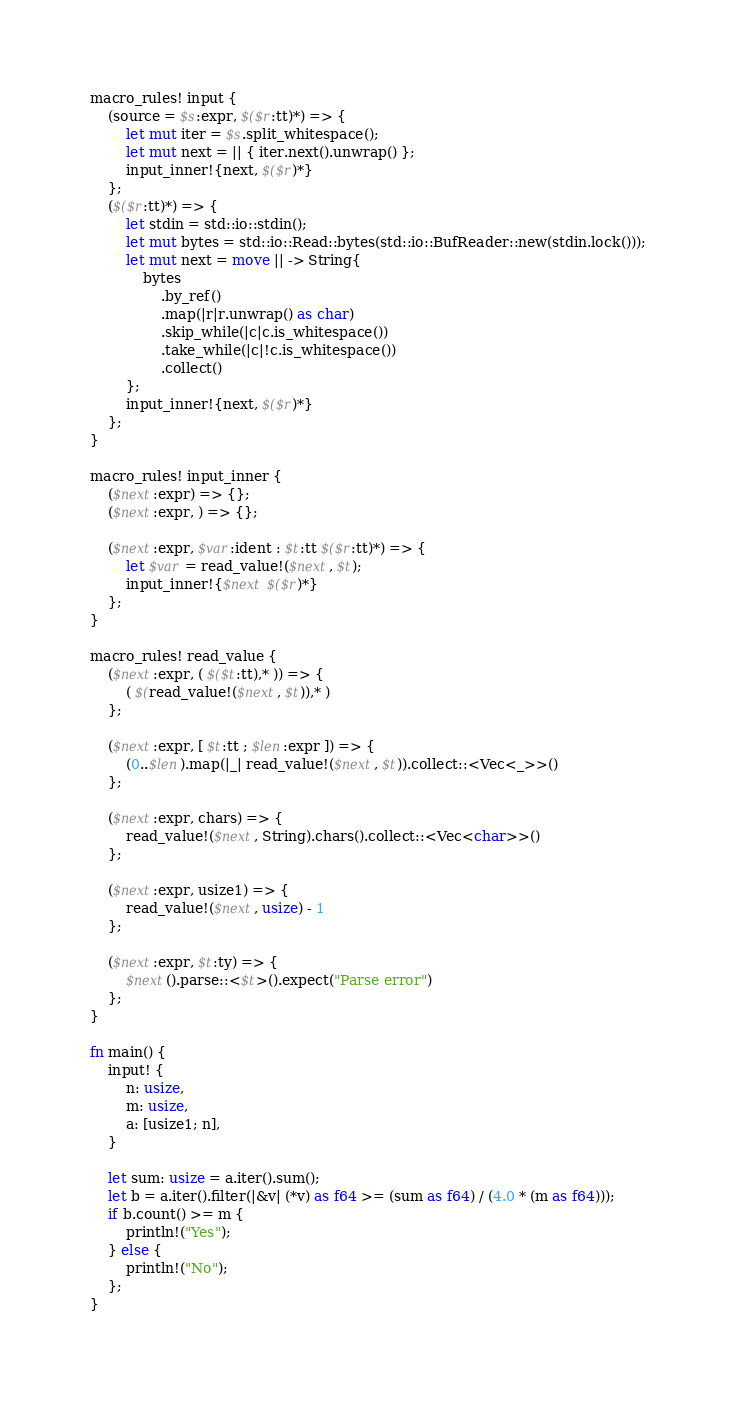<code> <loc_0><loc_0><loc_500><loc_500><_Rust_>macro_rules! input {
    (source = $s:expr, $($r:tt)*) => {
        let mut iter = $s.split_whitespace();
        let mut next = || { iter.next().unwrap() };
        input_inner!{next, $($r)*}
    };
    ($($r:tt)*) => {
        let stdin = std::io::stdin();
        let mut bytes = std::io::Read::bytes(std::io::BufReader::new(stdin.lock()));
        let mut next = move || -> String{
            bytes
                .by_ref()
                .map(|r|r.unwrap() as char)
                .skip_while(|c|c.is_whitespace())
                .take_while(|c|!c.is_whitespace())
                .collect()
        };
        input_inner!{next, $($r)*}
    };
}

macro_rules! input_inner {
    ($next:expr) => {};
    ($next:expr, ) => {};

    ($next:expr, $var:ident : $t:tt $($r:tt)*) => {
        let $var = read_value!($next, $t);
        input_inner!{$next $($r)*}
    };
}

macro_rules! read_value {
    ($next:expr, ( $($t:tt),* )) => {
        ( $(read_value!($next, $t)),* )
    };

    ($next:expr, [ $t:tt ; $len:expr ]) => {
        (0..$len).map(|_| read_value!($next, $t)).collect::<Vec<_>>()
    };

    ($next:expr, chars) => {
        read_value!($next, String).chars().collect::<Vec<char>>()
    };

    ($next:expr, usize1) => {
        read_value!($next, usize) - 1
    };

    ($next:expr, $t:ty) => {
        $next().parse::<$t>().expect("Parse error")
    };
}

fn main() {
    input! {
        n: usize,
        m: usize,
        a: [usize1; n],
    }

    let sum: usize = a.iter().sum();
    let b = a.iter().filter(|&v| (*v) as f64 >= (sum as f64) / (4.0 * (m as f64)));
    if b.count() >= m {
        println!("Yes");
    } else {
        println!("No");
    };
}</code> 